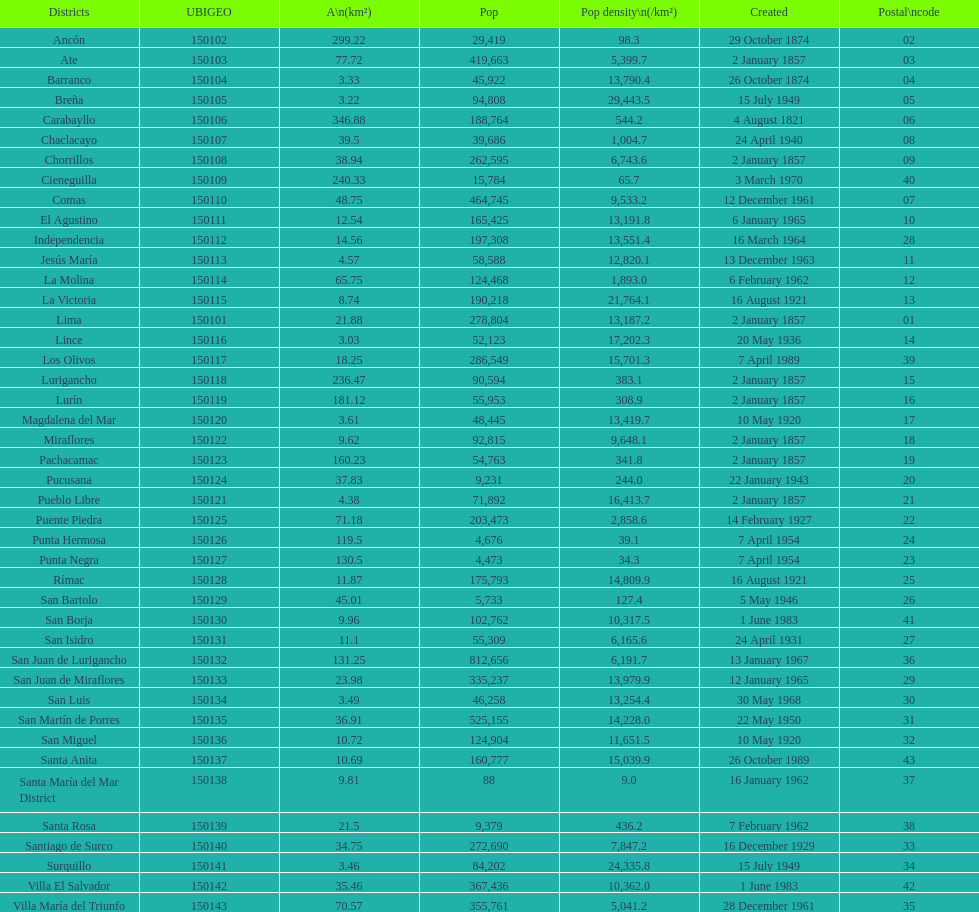What was the last district created? Santa Anita. 